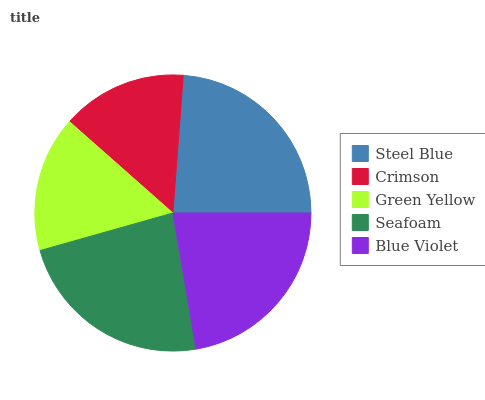Is Crimson the minimum?
Answer yes or no. Yes. Is Steel Blue the maximum?
Answer yes or no. Yes. Is Green Yellow the minimum?
Answer yes or no. No. Is Green Yellow the maximum?
Answer yes or no. No. Is Green Yellow greater than Crimson?
Answer yes or no. Yes. Is Crimson less than Green Yellow?
Answer yes or no. Yes. Is Crimson greater than Green Yellow?
Answer yes or no. No. Is Green Yellow less than Crimson?
Answer yes or no. No. Is Blue Violet the high median?
Answer yes or no. Yes. Is Blue Violet the low median?
Answer yes or no. Yes. Is Crimson the high median?
Answer yes or no. No. Is Steel Blue the low median?
Answer yes or no. No. 